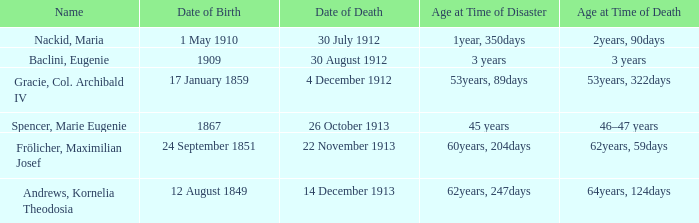When did the person born 24 September 1851 pass away? 22 November 1913. 